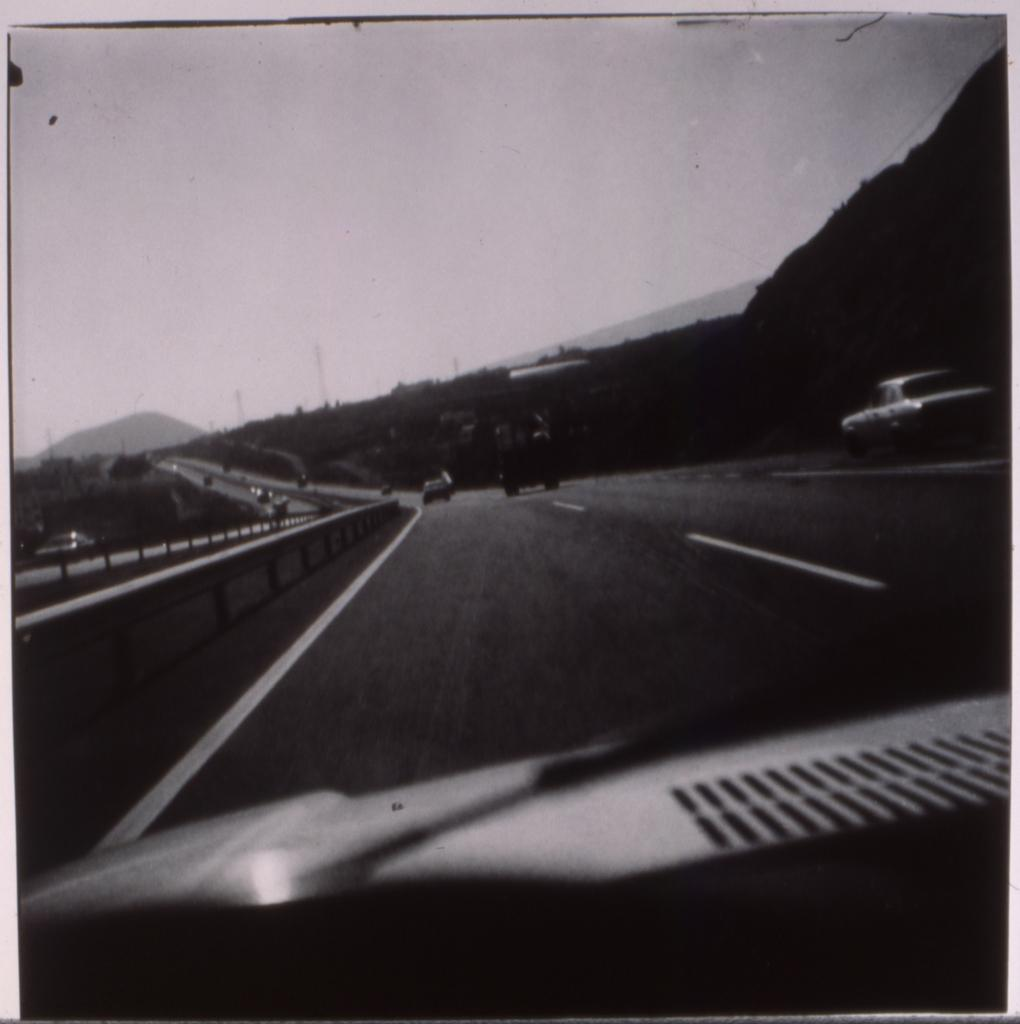What types of objects are present in the image? There are vehicles in the image. Where are the vehicles located? The vehicles are on a path. What type of drug can be seen in the image? There is no drug present in the image; it features vehicles on a path. 